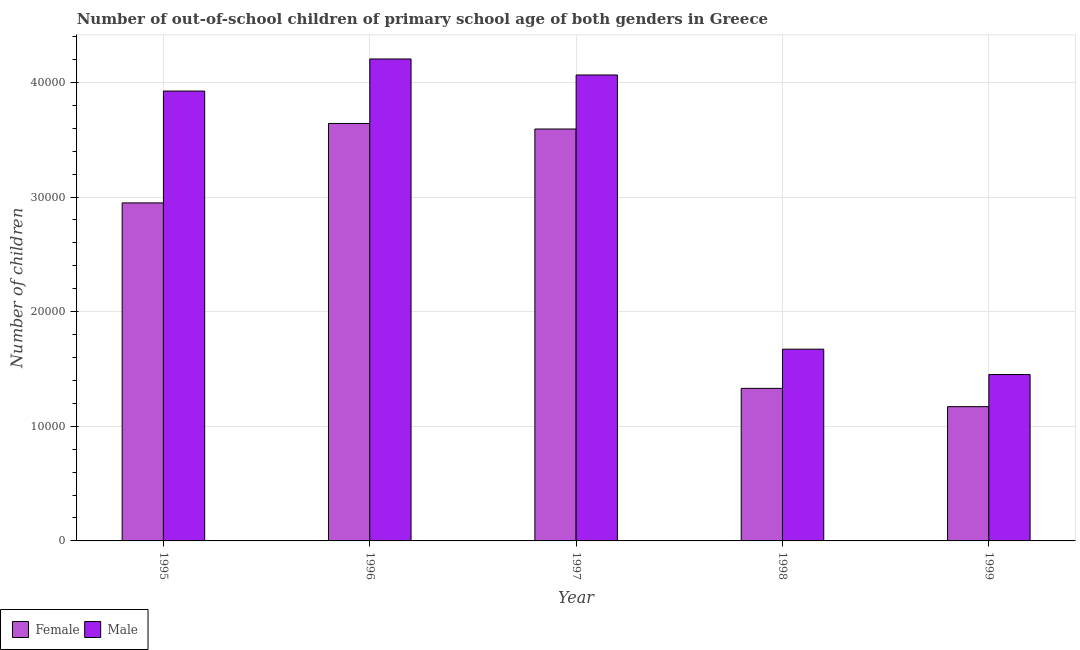How many different coloured bars are there?
Your answer should be compact. 2. How many groups of bars are there?
Your answer should be compact. 5. Are the number of bars per tick equal to the number of legend labels?
Provide a succinct answer. Yes. How many bars are there on the 3rd tick from the right?
Provide a short and direct response. 2. In how many cases, is the number of bars for a given year not equal to the number of legend labels?
Your answer should be compact. 0. What is the number of male out-of-school students in 1998?
Your answer should be compact. 1.67e+04. Across all years, what is the maximum number of female out-of-school students?
Give a very brief answer. 3.64e+04. Across all years, what is the minimum number of male out-of-school students?
Offer a very short reply. 1.45e+04. What is the total number of female out-of-school students in the graph?
Offer a very short reply. 1.27e+05. What is the difference between the number of male out-of-school students in 1996 and that in 1999?
Keep it short and to the point. 2.75e+04. What is the difference between the number of male out-of-school students in 1996 and the number of female out-of-school students in 1999?
Your response must be concise. 2.75e+04. What is the average number of male out-of-school students per year?
Give a very brief answer. 3.06e+04. In how many years, is the number of male out-of-school students greater than 2000?
Keep it short and to the point. 5. What is the ratio of the number of female out-of-school students in 1996 to that in 1999?
Keep it short and to the point. 3.11. Is the number of male out-of-school students in 1995 less than that in 1999?
Your answer should be compact. No. What is the difference between the highest and the second highest number of female out-of-school students?
Your response must be concise. 484. What is the difference between the highest and the lowest number of female out-of-school students?
Provide a succinct answer. 2.47e+04. What does the 1st bar from the right in 1995 represents?
Provide a short and direct response. Male. Are all the bars in the graph horizontal?
Your answer should be very brief. No. How many years are there in the graph?
Ensure brevity in your answer.  5. Does the graph contain any zero values?
Your response must be concise. No. Does the graph contain grids?
Your answer should be compact. Yes. How many legend labels are there?
Provide a succinct answer. 2. What is the title of the graph?
Your answer should be very brief. Number of out-of-school children of primary school age of both genders in Greece. What is the label or title of the Y-axis?
Your answer should be compact. Number of children. What is the Number of children in Female in 1995?
Give a very brief answer. 2.95e+04. What is the Number of children in Male in 1995?
Keep it short and to the point. 3.92e+04. What is the Number of children of Female in 1996?
Offer a very short reply. 3.64e+04. What is the Number of children of Male in 1996?
Give a very brief answer. 4.20e+04. What is the Number of children in Female in 1997?
Your response must be concise. 3.59e+04. What is the Number of children of Male in 1997?
Provide a succinct answer. 4.07e+04. What is the Number of children in Female in 1998?
Give a very brief answer. 1.33e+04. What is the Number of children of Male in 1998?
Ensure brevity in your answer.  1.67e+04. What is the Number of children of Female in 1999?
Ensure brevity in your answer.  1.17e+04. What is the Number of children in Male in 1999?
Your answer should be very brief. 1.45e+04. Across all years, what is the maximum Number of children of Female?
Your answer should be compact. 3.64e+04. Across all years, what is the maximum Number of children of Male?
Your answer should be very brief. 4.20e+04. Across all years, what is the minimum Number of children in Female?
Offer a terse response. 1.17e+04. Across all years, what is the minimum Number of children in Male?
Your response must be concise. 1.45e+04. What is the total Number of children in Female in the graph?
Give a very brief answer. 1.27e+05. What is the total Number of children of Male in the graph?
Offer a terse response. 1.53e+05. What is the difference between the Number of children in Female in 1995 and that in 1996?
Provide a succinct answer. -6931. What is the difference between the Number of children of Male in 1995 and that in 1996?
Your answer should be compact. -2799. What is the difference between the Number of children in Female in 1995 and that in 1997?
Your answer should be compact. -6447. What is the difference between the Number of children in Male in 1995 and that in 1997?
Your answer should be compact. -1403. What is the difference between the Number of children of Female in 1995 and that in 1998?
Offer a terse response. 1.62e+04. What is the difference between the Number of children of Male in 1995 and that in 1998?
Give a very brief answer. 2.25e+04. What is the difference between the Number of children of Female in 1995 and that in 1999?
Your answer should be compact. 1.78e+04. What is the difference between the Number of children of Male in 1995 and that in 1999?
Give a very brief answer. 2.47e+04. What is the difference between the Number of children of Female in 1996 and that in 1997?
Keep it short and to the point. 484. What is the difference between the Number of children of Male in 1996 and that in 1997?
Your answer should be very brief. 1396. What is the difference between the Number of children in Female in 1996 and that in 1998?
Your answer should be compact. 2.31e+04. What is the difference between the Number of children in Male in 1996 and that in 1998?
Ensure brevity in your answer.  2.53e+04. What is the difference between the Number of children of Female in 1996 and that in 1999?
Give a very brief answer. 2.47e+04. What is the difference between the Number of children in Male in 1996 and that in 1999?
Provide a succinct answer. 2.75e+04. What is the difference between the Number of children in Female in 1997 and that in 1998?
Offer a terse response. 2.26e+04. What is the difference between the Number of children of Male in 1997 and that in 1998?
Provide a succinct answer. 2.39e+04. What is the difference between the Number of children of Female in 1997 and that in 1999?
Give a very brief answer. 2.42e+04. What is the difference between the Number of children in Male in 1997 and that in 1999?
Your answer should be very brief. 2.61e+04. What is the difference between the Number of children of Female in 1998 and that in 1999?
Provide a succinct answer. 1594. What is the difference between the Number of children in Male in 1998 and that in 1999?
Your response must be concise. 2211. What is the difference between the Number of children of Female in 1995 and the Number of children of Male in 1996?
Offer a terse response. -1.26e+04. What is the difference between the Number of children of Female in 1995 and the Number of children of Male in 1997?
Your response must be concise. -1.12e+04. What is the difference between the Number of children of Female in 1995 and the Number of children of Male in 1998?
Your answer should be very brief. 1.28e+04. What is the difference between the Number of children of Female in 1995 and the Number of children of Male in 1999?
Offer a terse response. 1.50e+04. What is the difference between the Number of children of Female in 1996 and the Number of children of Male in 1997?
Ensure brevity in your answer.  -4230. What is the difference between the Number of children in Female in 1996 and the Number of children in Male in 1998?
Provide a succinct answer. 1.97e+04. What is the difference between the Number of children in Female in 1996 and the Number of children in Male in 1999?
Keep it short and to the point. 2.19e+04. What is the difference between the Number of children of Female in 1997 and the Number of children of Male in 1998?
Keep it short and to the point. 1.92e+04. What is the difference between the Number of children in Female in 1997 and the Number of children in Male in 1999?
Your answer should be compact. 2.14e+04. What is the difference between the Number of children of Female in 1998 and the Number of children of Male in 1999?
Give a very brief answer. -1208. What is the average Number of children of Female per year?
Keep it short and to the point. 2.54e+04. What is the average Number of children of Male per year?
Provide a short and direct response. 3.06e+04. In the year 1995, what is the difference between the Number of children in Female and Number of children in Male?
Provide a succinct answer. -9758. In the year 1996, what is the difference between the Number of children in Female and Number of children in Male?
Offer a terse response. -5626. In the year 1997, what is the difference between the Number of children of Female and Number of children of Male?
Provide a succinct answer. -4714. In the year 1998, what is the difference between the Number of children of Female and Number of children of Male?
Your answer should be very brief. -3419. In the year 1999, what is the difference between the Number of children in Female and Number of children in Male?
Your answer should be very brief. -2802. What is the ratio of the Number of children in Female in 1995 to that in 1996?
Your answer should be compact. 0.81. What is the ratio of the Number of children of Male in 1995 to that in 1996?
Your answer should be very brief. 0.93. What is the ratio of the Number of children of Female in 1995 to that in 1997?
Your answer should be compact. 0.82. What is the ratio of the Number of children in Male in 1995 to that in 1997?
Make the answer very short. 0.97. What is the ratio of the Number of children in Female in 1995 to that in 1998?
Provide a succinct answer. 2.22. What is the ratio of the Number of children of Male in 1995 to that in 1998?
Your answer should be compact. 2.35. What is the ratio of the Number of children in Female in 1995 to that in 1999?
Keep it short and to the point. 2.52. What is the ratio of the Number of children in Male in 1995 to that in 1999?
Keep it short and to the point. 2.7. What is the ratio of the Number of children in Female in 1996 to that in 1997?
Your response must be concise. 1.01. What is the ratio of the Number of children of Male in 1996 to that in 1997?
Make the answer very short. 1.03. What is the ratio of the Number of children in Female in 1996 to that in 1998?
Ensure brevity in your answer.  2.74. What is the ratio of the Number of children in Male in 1996 to that in 1998?
Ensure brevity in your answer.  2.51. What is the ratio of the Number of children of Female in 1996 to that in 1999?
Your response must be concise. 3.11. What is the ratio of the Number of children in Male in 1996 to that in 1999?
Provide a succinct answer. 2.9. What is the ratio of the Number of children of Female in 1997 to that in 1998?
Your response must be concise. 2.7. What is the ratio of the Number of children in Male in 1997 to that in 1998?
Offer a terse response. 2.43. What is the ratio of the Number of children in Female in 1997 to that in 1999?
Keep it short and to the point. 3.07. What is the ratio of the Number of children of Male in 1997 to that in 1999?
Keep it short and to the point. 2.8. What is the ratio of the Number of children of Female in 1998 to that in 1999?
Keep it short and to the point. 1.14. What is the ratio of the Number of children in Male in 1998 to that in 1999?
Offer a very short reply. 1.15. What is the difference between the highest and the second highest Number of children of Female?
Your answer should be very brief. 484. What is the difference between the highest and the second highest Number of children in Male?
Ensure brevity in your answer.  1396. What is the difference between the highest and the lowest Number of children in Female?
Provide a short and direct response. 2.47e+04. What is the difference between the highest and the lowest Number of children of Male?
Offer a very short reply. 2.75e+04. 